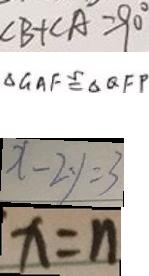Convert formula to latex. <formula><loc_0><loc_0><loc_500><loc_500>\angle B + \angle A = 9 0 ^ { \circ } 
 \Delta G A F \cong \Delta Q F P 
 x - 2 y = 3 
 x = n</formula> 